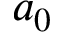<formula> <loc_0><loc_0><loc_500><loc_500>a _ { 0 }</formula> 